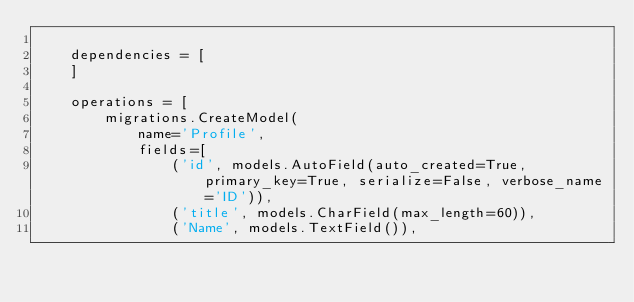<code> <loc_0><loc_0><loc_500><loc_500><_Python_>
    dependencies = [
    ]

    operations = [
        migrations.CreateModel(
            name='Profile',
            fields=[
                ('id', models.AutoField(auto_created=True, primary_key=True, serialize=False, verbose_name='ID')),
                ('title', models.CharField(max_length=60)),
                ('Name', models.TextField()),</code> 